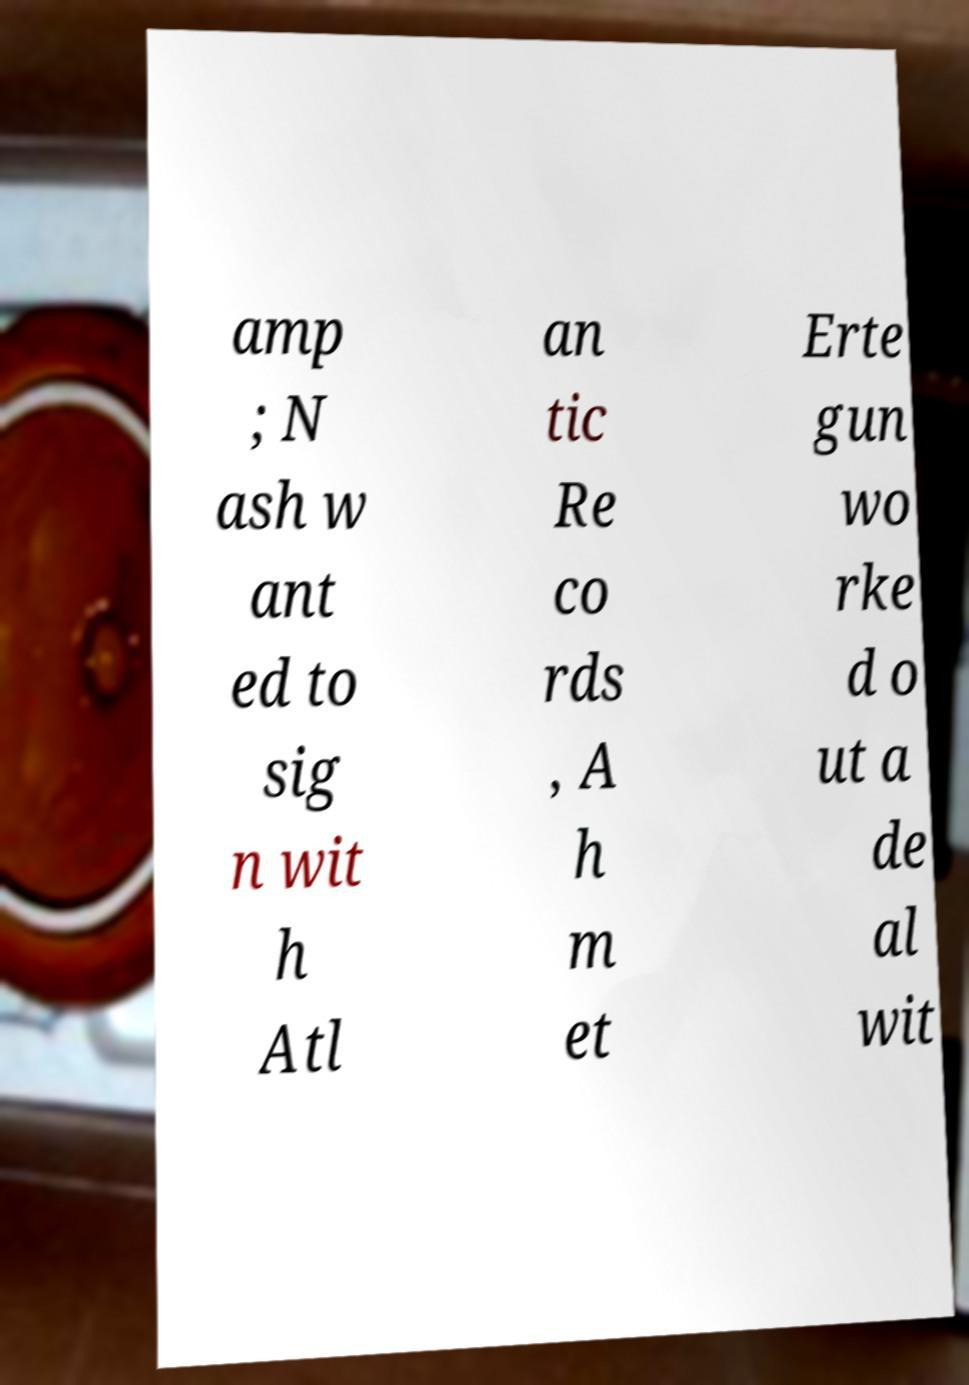Could you assist in decoding the text presented in this image and type it out clearly? amp ; N ash w ant ed to sig n wit h Atl an tic Re co rds , A h m et Erte gun wo rke d o ut a de al wit 